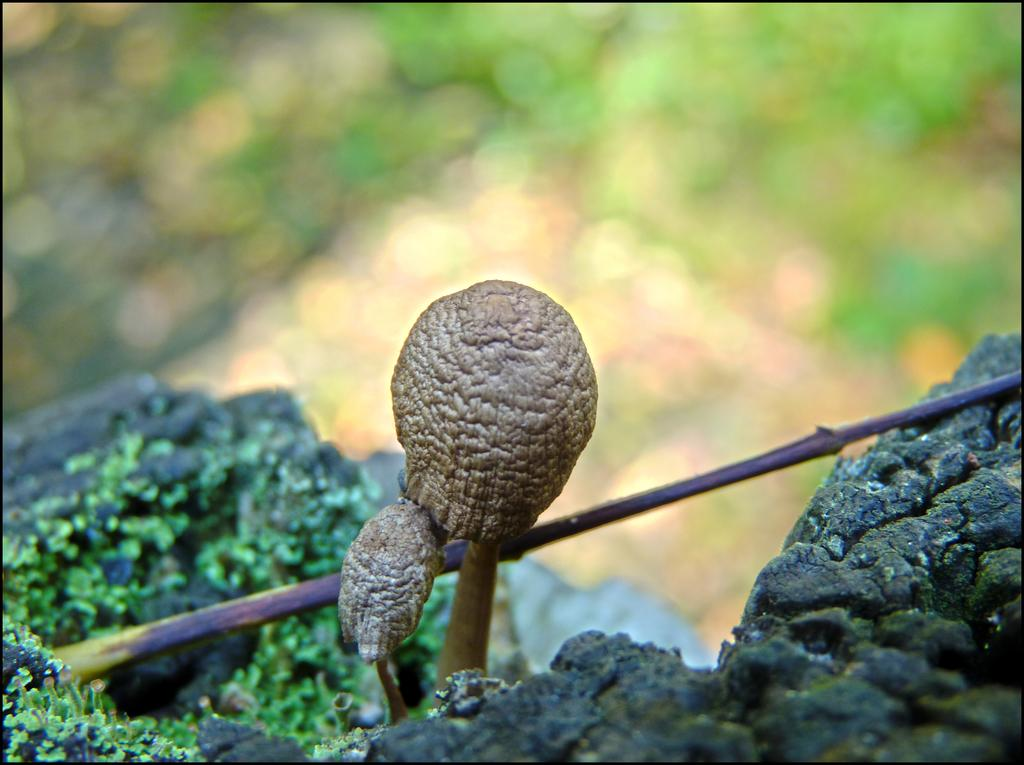What is the main subject in the front of the image? There is a mushroom in the front of the image. What type of vegetation can be seen in the image? There are leaves in the image. How would you describe the background of the image? The background of the image is blurry. What type of property is for sale in the image? There is no property or indication of a sale in the image; it primarily features a mushroom and leaves. 